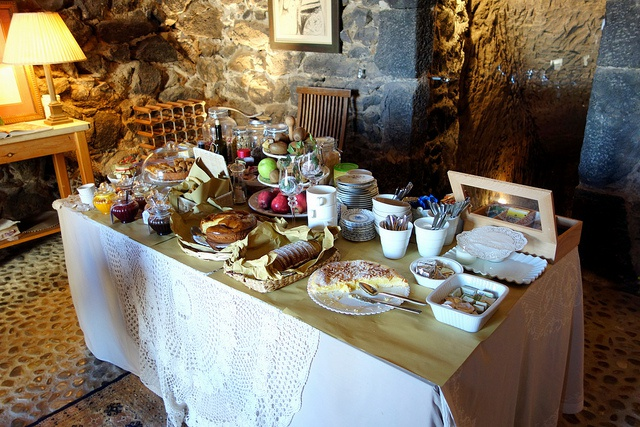Describe the objects in this image and their specific colors. I can see dining table in maroon, lightblue, and darkgray tones, bowl in maroon, lightblue, gray, and darkgray tones, chair in maroon, black, and gray tones, cake in maroon, ivory, darkgray, khaki, and gray tones, and cake in maroon, brown, black, and gray tones in this image. 